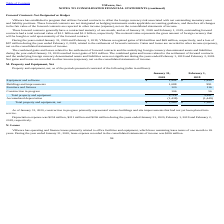According to Vmware's financial document, What did construction in progress primarily represented as of 2020? various buildings and site improvements that had not yet been placed into service.. The document states: "20, construction in progress primarily represented various buildings and site improvements that had not yet been placed into service...." Also, What was the depreciation expense in 2020? According to the financial document, $234 million. The relevant text states: "Depreciation expense was $234 million, $211 million and $206 million during the years ended January 31, 2020, February 1, 2019 and Februa..." Also, What was the amount of construction in progress in 2020? According to the financial document, 106 (in millions). The relevant text states: "Construction in progress 106 56..." Also, can you calculate: What was the change in Total property and equipment between 2019 and 2020? Based on the calculation: 2,718-2,611, the result is 107 (in millions). This is based on the information: "Total property and equipment 2,718 2,611 Total property and equipment 2,718 2,611..." The key data points involved are: 2,611, 2,718. Also, Which years did construction in progress exceed $100 million? Based on the analysis, there are 1 instances. The counting process: 2020. Also, can you calculate: What was the percentage change in the net total property and equipment between 2019 and 2020? To answer this question, I need to perform calculations using the financial data. The calculation is: (1,280-1,162)/1,162, which equals 10.15 (percentage). This is based on the information: "Total property and equipment, net $ 1,280 $ 1,162 Total property and equipment, net $ 1,280 $ 1,162..." The key data points involved are: 1,162, 1,280. 